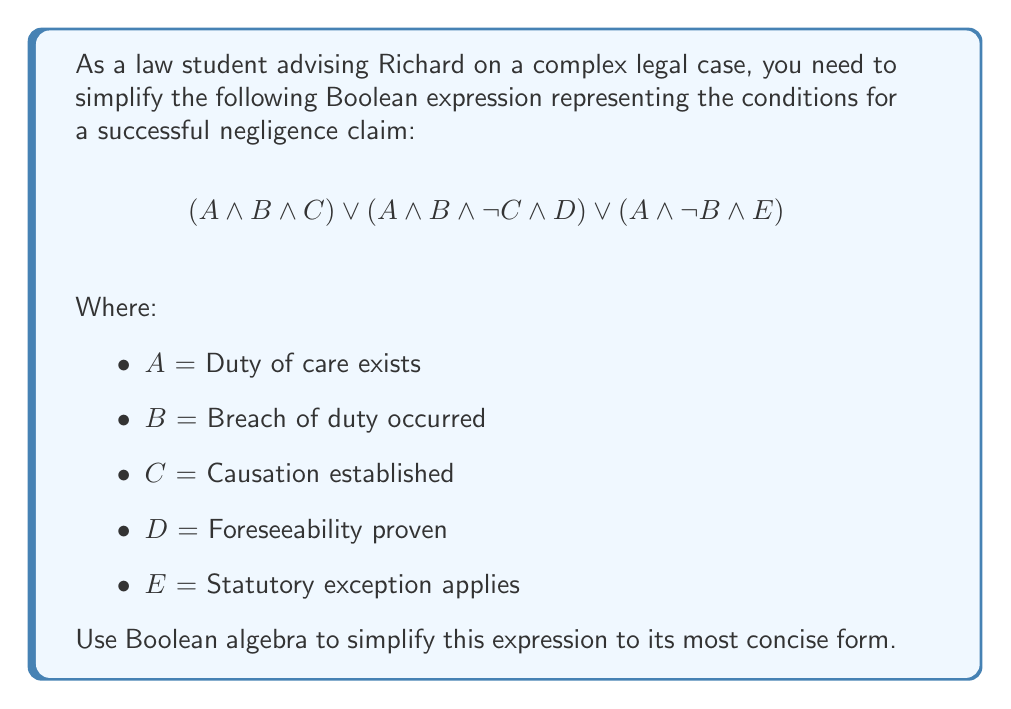Solve this math problem. Let's simplify this expression step by step using Boolean algebra laws:

1) First, let's factor out the common term A:
   $$A \land [(B \land C) \lor (B \land \lnot C \land D) \lor (\lnot B \land E)]$$

2) Now, let's focus on the part inside the square brackets. We can factor out B from the first two terms:
   $$A \land [B(C \lor (\lnot C \land D)) \lor (\lnot B \land E)]$$

3) Let's simplify $(C \lor (\lnot C \land D))$ using the absorption law:
   $C \lor (\lnot C \land D) = C \lor D$

4) Substituting this back:
   $$A \land [B(C \lor D) \lor (\lnot B \land E)]$$

5) Now we can use the distributive law to expand this:
   $$A \land [(B \land C) \lor (B \land D) \lor (\lnot B \land E)]$$

6) This is the most simplified form using standard Boolean algebra. However, in legal terms, we can interpret this as:

   "A successful negligence claim requires a duty of care (A) AND either:
   - a breach of duty and causation (B and C), OR
   - a breach of duty and foreseeability (B and D), OR
   - a statutory exception applies (E) even without a breach of duty (not B)"

This simplified form clearly shows the different paths to establish a negligence claim, making it easier for Richard to understand and apply in his legal reasoning.
Answer: $$A \land [(B \land C) \lor (B \land D) \lor (\lnot B \land E)]$$ 